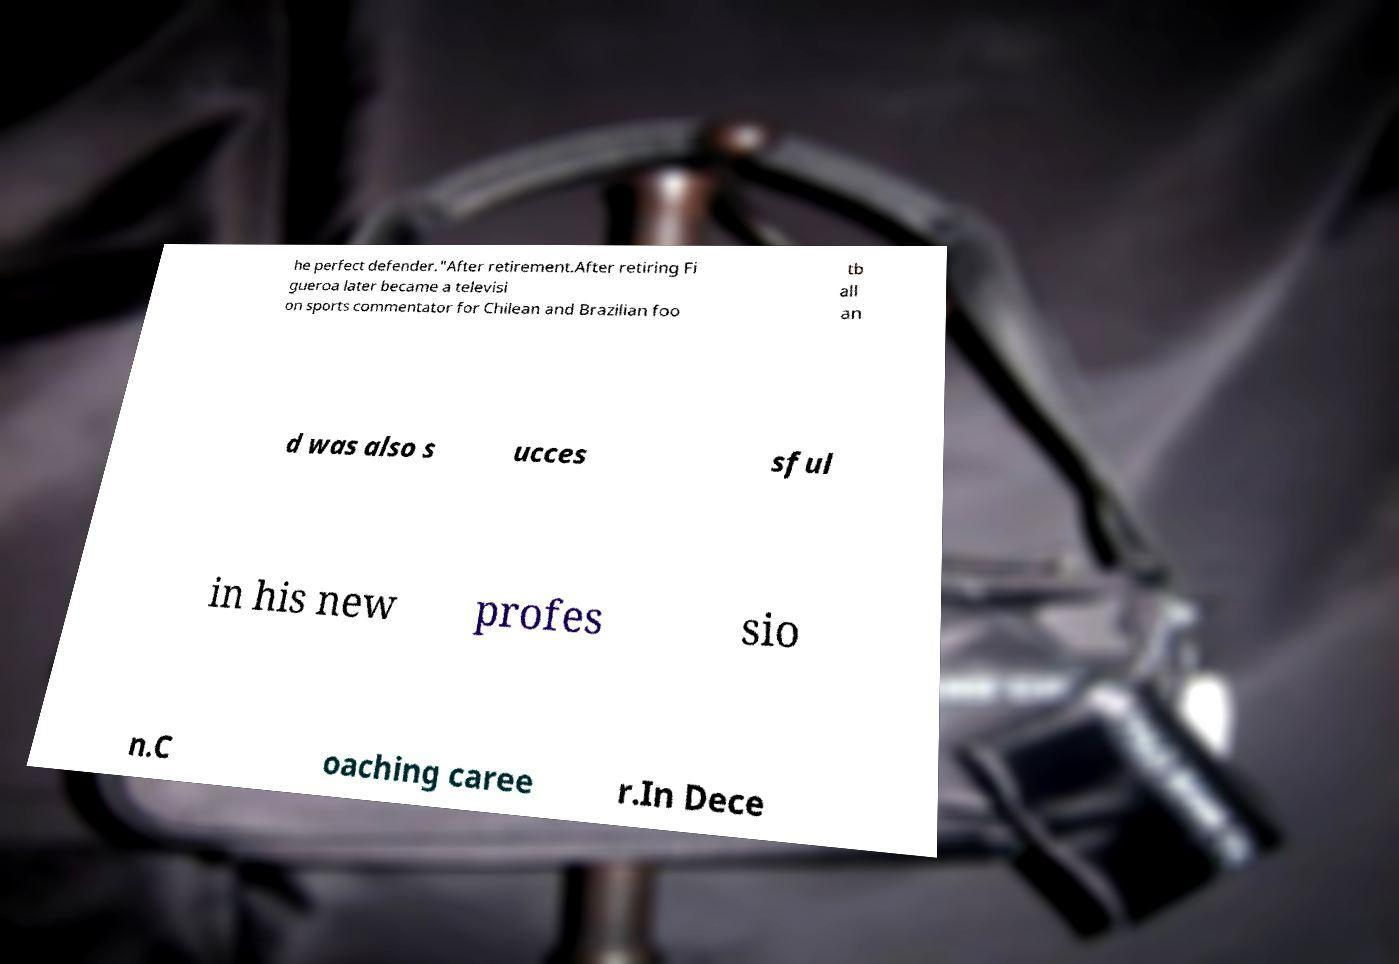Please identify and transcribe the text found in this image. he perfect defender."After retirement.After retiring Fi gueroa later became a televisi on sports commentator for Chilean and Brazilian foo tb all an d was also s ucces sful in his new profes sio n.C oaching caree r.In Dece 